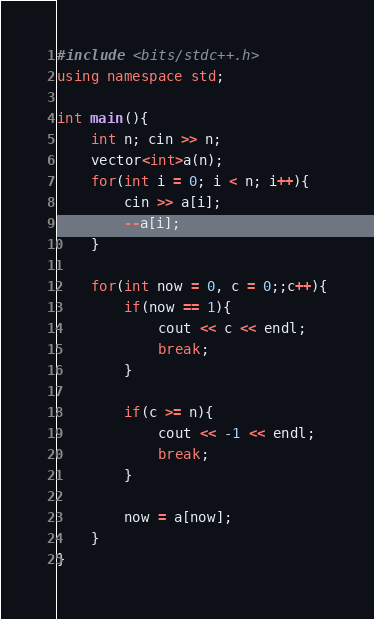Convert code to text. <code><loc_0><loc_0><loc_500><loc_500><_C++_>#include <bits/stdc++.h>
using namespace std;

int main(){
    int n; cin >> n;
    vector<int>a(n);
    for(int i = 0; i < n; i++){
        cin >> a[i];
        --a[i];
    }

    for(int now = 0, c = 0;;c++){
        if(now == 1){
            cout << c << endl;
            break;
        }

        if(c >= n){
            cout << -1 << endl;
            break;
        }
        
        now = a[now];
    }
}</code> 